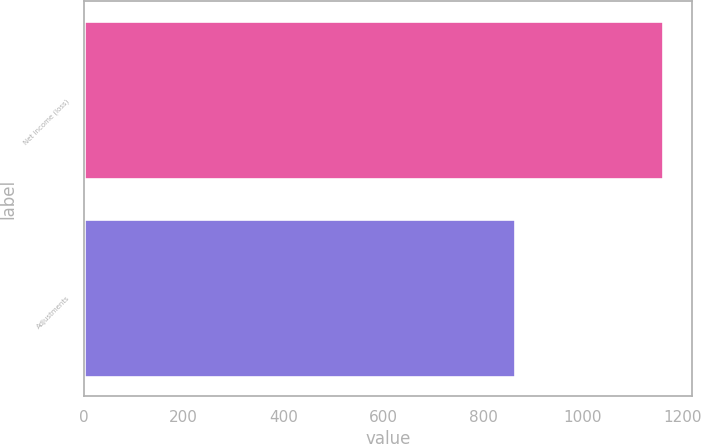Convert chart. <chart><loc_0><loc_0><loc_500><loc_500><bar_chart><fcel>Net income (loss)<fcel>Adjustments<nl><fcel>1160<fcel>864<nl></chart> 